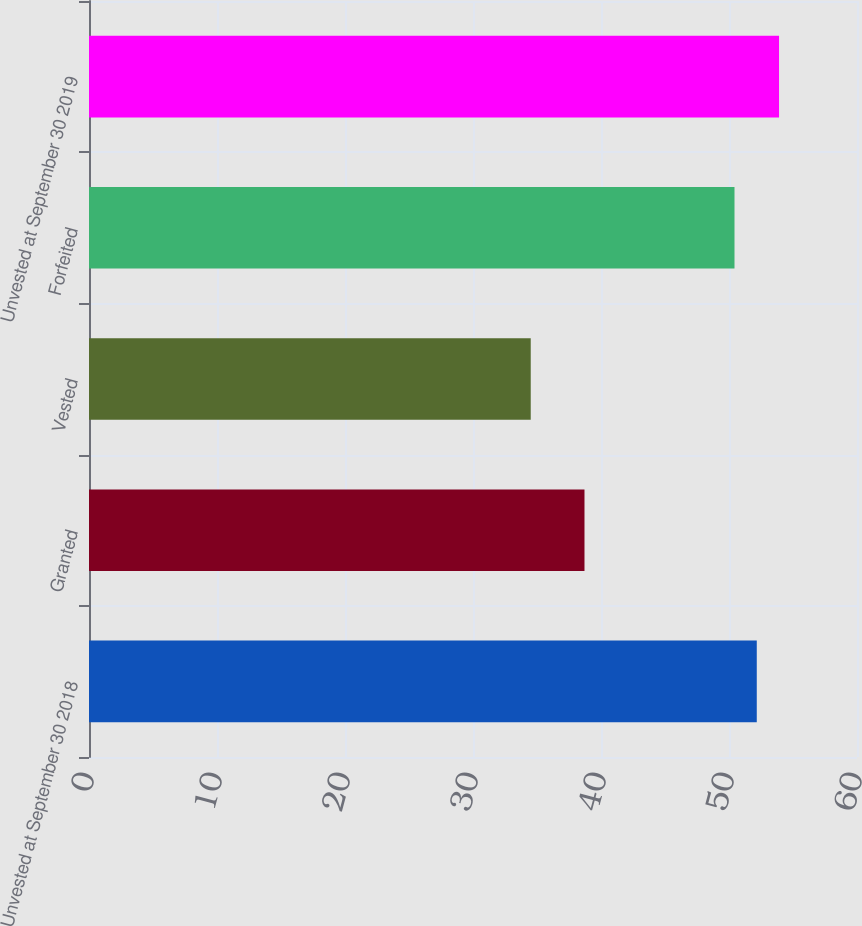Convert chart. <chart><loc_0><loc_0><loc_500><loc_500><bar_chart><fcel>Unvested at September 30 2018<fcel>Granted<fcel>Vested<fcel>Forfeited<fcel>Unvested at September 30 2019<nl><fcel>52.17<fcel>38.71<fcel>34.51<fcel>50.43<fcel>53.91<nl></chart> 